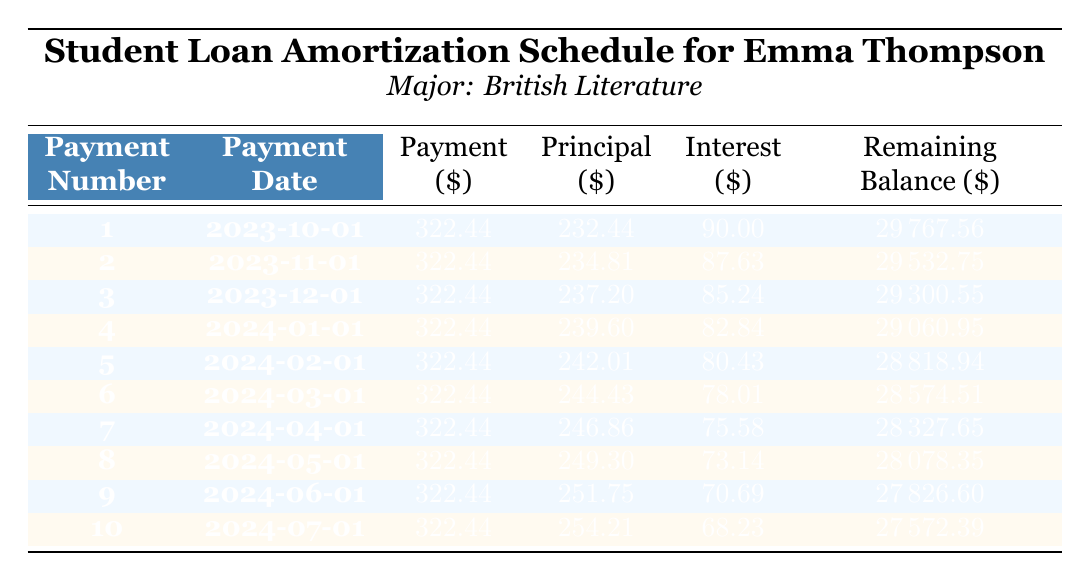What is the total loan amount for Emma Thompson? The table shows that the loan amount is listed under loan_details, where it specifically states the loan amount as 30000.
Answer: 30000 How much is the monthly payment for Emma's loan? The monthly payment is mentioned in the loan_details section of the table, specifically citing that it is 322.44.
Answer: 322.44 What is the remaining balance after the first payment? According to the amortization schedule in the first row, the remaining balance after the first payment on 2023-10-01 is shown as 29767.56.
Answer: 29767.56 How much principal is paid off in the third payment? From the third row in the amortization schedule, we see that the principal repayment for the third payment, dated 2023-12-01, is 237.20.
Answer: 237.20 What is the total interest paid in the first three payments? To find the total interest paid in the first three payments, we sum the interest from the first three rows: 90.00 (first payment) + 87.63 (second payment) + 85.24 (third payment) = 262.87.
Answer: 262.87 Is Emma's monthly payment consistent throughout the schedule? The table shows that the monthly payment, which is listed as 322.44 for each payment, indicates that it is consistent across all payments.
Answer: Yes What is the average principal payment for the first five payments? To calculate the average principal payment, we need the principal values from the first five payments: 232.44, 234.81, 237.20, 239.60, and 242.01. Adding these gives a sum of 1186.06, and dividing by 5 yields an average of 237.21.
Answer: 237.21 How much does the remaining balance decrease from the first to the second payment? The remaining balance after the first payment is 29767.56, and after the second payment, it is 29532.75. The decrease is calculated as 29767.56 - 29532.75 = 234.81.
Answer: 234.81 What is the difference in interest paid between the fourth and fifth payments? The interest paid in the fourth payment is 82.84 and in the fifth payment is 80.43. To find the difference, subtract the fifth from the fourth: 82.84 - 80.43 = 2.41.
Answer: 2.41 How many payments are required to fully pay off the loan? The loan term given in the loan details is 10 years. Since payments are made monthly, the total number of payments required would be 10 years multiplied by 12 months per year: 10 * 12 = 120 payments.
Answer: 120 